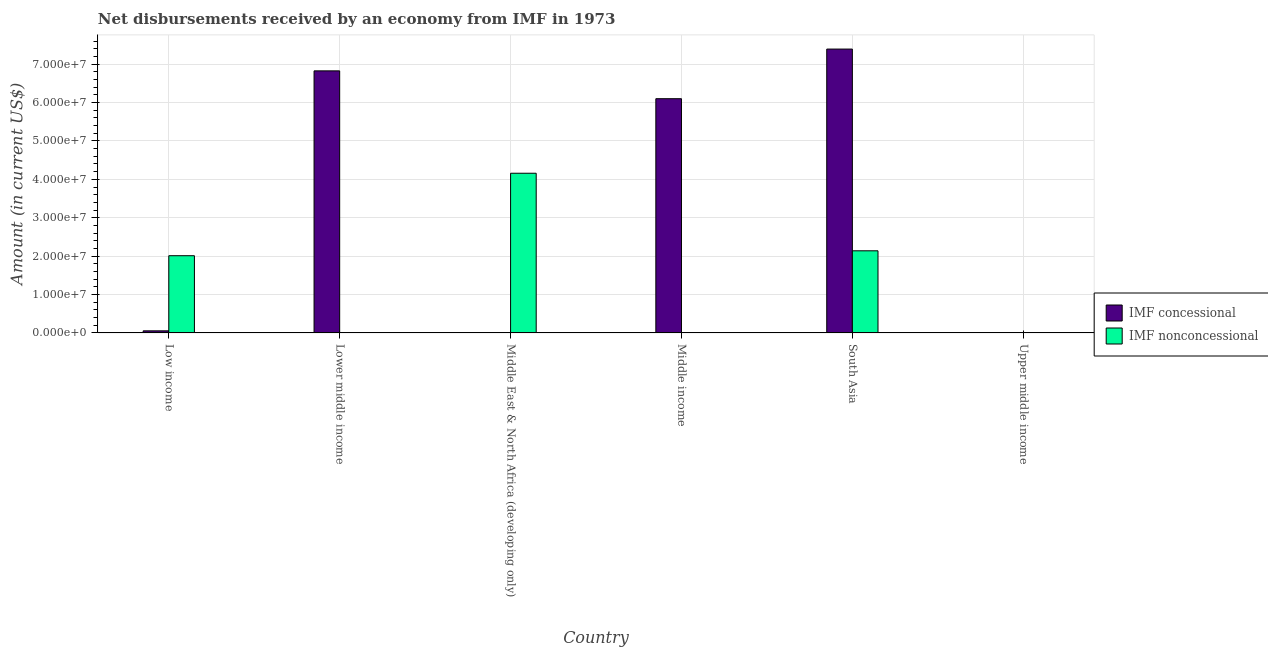How many different coloured bars are there?
Provide a short and direct response. 2. Are the number of bars per tick equal to the number of legend labels?
Ensure brevity in your answer.  No. Are the number of bars on each tick of the X-axis equal?
Provide a succinct answer. No. What is the label of the 6th group of bars from the left?
Offer a terse response. Upper middle income. What is the net concessional disbursements from imf in Middle income?
Give a very brief answer. 6.10e+07. Across all countries, what is the maximum net concessional disbursements from imf?
Keep it short and to the point. 7.39e+07. Across all countries, what is the minimum net non concessional disbursements from imf?
Make the answer very short. 0. In which country was the net concessional disbursements from imf maximum?
Your answer should be compact. South Asia. What is the total net concessional disbursements from imf in the graph?
Give a very brief answer. 2.04e+08. What is the difference between the net non concessional disbursements from imf in Middle East & North Africa (developing only) and that in South Asia?
Offer a very short reply. 2.02e+07. What is the difference between the net non concessional disbursements from imf in Lower middle income and the net concessional disbursements from imf in Middle income?
Keep it short and to the point. -6.10e+07. What is the average net concessional disbursements from imf per country?
Your answer should be very brief. 3.40e+07. What is the difference between the net non concessional disbursements from imf and net concessional disbursements from imf in Low income?
Give a very brief answer. 1.96e+07. What is the ratio of the net concessional disbursements from imf in Low income to that in Middle income?
Provide a succinct answer. 0.01. What is the difference between the highest and the second highest net non concessional disbursements from imf?
Make the answer very short. 2.02e+07. What is the difference between the highest and the lowest net concessional disbursements from imf?
Provide a short and direct response. 7.39e+07. What is the difference between two consecutive major ticks on the Y-axis?
Provide a short and direct response. 1.00e+07. Does the graph contain any zero values?
Provide a short and direct response. Yes. Does the graph contain grids?
Keep it short and to the point. Yes. Where does the legend appear in the graph?
Make the answer very short. Center right. How many legend labels are there?
Offer a very short reply. 2. What is the title of the graph?
Offer a very short reply. Net disbursements received by an economy from IMF in 1973. What is the label or title of the X-axis?
Offer a terse response. Country. What is the Amount (in current US$) in IMF concessional in Low income?
Give a very brief answer. 5.46e+05. What is the Amount (in current US$) in IMF nonconcessional in Low income?
Ensure brevity in your answer.  2.01e+07. What is the Amount (in current US$) in IMF concessional in Lower middle income?
Give a very brief answer. 6.83e+07. What is the Amount (in current US$) in IMF nonconcessional in Lower middle income?
Your answer should be very brief. 0. What is the Amount (in current US$) in IMF concessional in Middle East & North Africa (developing only)?
Provide a short and direct response. 0. What is the Amount (in current US$) in IMF nonconcessional in Middle East & North Africa (developing only)?
Make the answer very short. 4.16e+07. What is the Amount (in current US$) of IMF concessional in Middle income?
Offer a terse response. 6.10e+07. What is the Amount (in current US$) in IMF concessional in South Asia?
Make the answer very short. 7.39e+07. What is the Amount (in current US$) of IMF nonconcessional in South Asia?
Offer a very short reply. 2.14e+07. What is the Amount (in current US$) in IMF concessional in Upper middle income?
Provide a succinct answer. 0. Across all countries, what is the maximum Amount (in current US$) in IMF concessional?
Offer a very short reply. 7.39e+07. Across all countries, what is the maximum Amount (in current US$) of IMF nonconcessional?
Ensure brevity in your answer.  4.16e+07. Across all countries, what is the minimum Amount (in current US$) in IMF concessional?
Your answer should be very brief. 0. Across all countries, what is the minimum Amount (in current US$) of IMF nonconcessional?
Your response must be concise. 0. What is the total Amount (in current US$) of IMF concessional in the graph?
Your answer should be compact. 2.04e+08. What is the total Amount (in current US$) of IMF nonconcessional in the graph?
Offer a terse response. 8.31e+07. What is the difference between the Amount (in current US$) in IMF concessional in Low income and that in Lower middle income?
Give a very brief answer. -6.77e+07. What is the difference between the Amount (in current US$) in IMF nonconcessional in Low income and that in Middle East & North Africa (developing only)?
Offer a very short reply. -2.15e+07. What is the difference between the Amount (in current US$) in IMF concessional in Low income and that in Middle income?
Provide a succinct answer. -6.05e+07. What is the difference between the Amount (in current US$) in IMF concessional in Low income and that in South Asia?
Give a very brief answer. -7.34e+07. What is the difference between the Amount (in current US$) of IMF nonconcessional in Low income and that in South Asia?
Your answer should be very brief. -1.28e+06. What is the difference between the Amount (in current US$) in IMF concessional in Lower middle income and that in Middle income?
Give a very brief answer. 7.25e+06. What is the difference between the Amount (in current US$) of IMF concessional in Lower middle income and that in South Asia?
Your response must be concise. -5.68e+06. What is the difference between the Amount (in current US$) in IMF nonconcessional in Middle East & North Africa (developing only) and that in South Asia?
Your response must be concise. 2.02e+07. What is the difference between the Amount (in current US$) in IMF concessional in Middle income and that in South Asia?
Offer a very short reply. -1.29e+07. What is the difference between the Amount (in current US$) in IMF concessional in Low income and the Amount (in current US$) in IMF nonconcessional in Middle East & North Africa (developing only)?
Your answer should be compact. -4.10e+07. What is the difference between the Amount (in current US$) in IMF concessional in Low income and the Amount (in current US$) in IMF nonconcessional in South Asia?
Your answer should be compact. -2.08e+07. What is the difference between the Amount (in current US$) in IMF concessional in Lower middle income and the Amount (in current US$) in IMF nonconcessional in Middle East & North Africa (developing only)?
Make the answer very short. 2.67e+07. What is the difference between the Amount (in current US$) in IMF concessional in Lower middle income and the Amount (in current US$) in IMF nonconcessional in South Asia?
Offer a terse response. 4.69e+07. What is the difference between the Amount (in current US$) of IMF concessional in Middle income and the Amount (in current US$) of IMF nonconcessional in South Asia?
Offer a very short reply. 3.96e+07. What is the average Amount (in current US$) of IMF concessional per country?
Keep it short and to the point. 3.40e+07. What is the average Amount (in current US$) in IMF nonconcessional per country?
Ensure brevity in your answer.  1.38e+07. What is the difference between the Amount (in current US$) in IMF concessional and Amount (in current US$) in IMF nonconcessional in Low income?
Keep it short and to the point. -1.96e+07. What is the difference between the Amount (in current US$) of IMF concessional and Amount (in current US$) of IMF nonconcessional in South Asia?
Make the answer very short. 5.25e+07. What is the ratio of the Amount (in current US$) in IMF concessional in Low income to that in Lower middle income?
Make the answer very short. 0.01. What is the ratio of the Amount (in current US$) in IMF nonconcessional in Low income to that in Middle East & North Africa (developing only)?
Offer a terse response. 0.48. What is the ratio of the Amount (in current US$) in IMF concessional in Low income to that in Middle income?
Your response must be concise. 0.01. What is the ratio of the Amount (in current US$) of IMF concessional in Low income to that in South Asia?
Ensure brevity in your answer.  0.01. What is the ratio of the Amount (in current US$) of IMF nonconcessional in Low income to that in South Asia?
Offer a very short reply. 0.94. What is the ratio of the Amount (in current US$) in IMF concessional in Lower middle income to that in Middle income?
Make the answer very short. 1.12. What is the ratio of the Amount (in current US$) in IMF concessional in Lower middle income to that in South Asia?
Your response must be concise. 0.92. What is the ratio of the Amount (in current US$) of IMF nonconcessional in Middle East & North Africa (developing only) to that in South Asia?
Offer a terse response. 1.94. What is the ratio of the Amount (in current US$) of IMF concessional in Middle income to that in South Asia?
Your response must be concise. 0.83. What is the difference between the highest and the second highest Amount (in current US$) of IMF concessional?
Keep it short and to the point. 5.68e+06. What is the difference between the highest and the second highest Amount (in current US$) of IMF nonconcessional?
Your answer should be compact. 2.02e+07. What is the difference between the highest and the lowest Amount (in current US$) in IMF concessional?
Provide a short and direct response. 7.39e+07. What is the difference between the highest and the lowest Amount (in current US$) in IMF nonconcessional?
Give a very brief answer. 4.16e+07. 